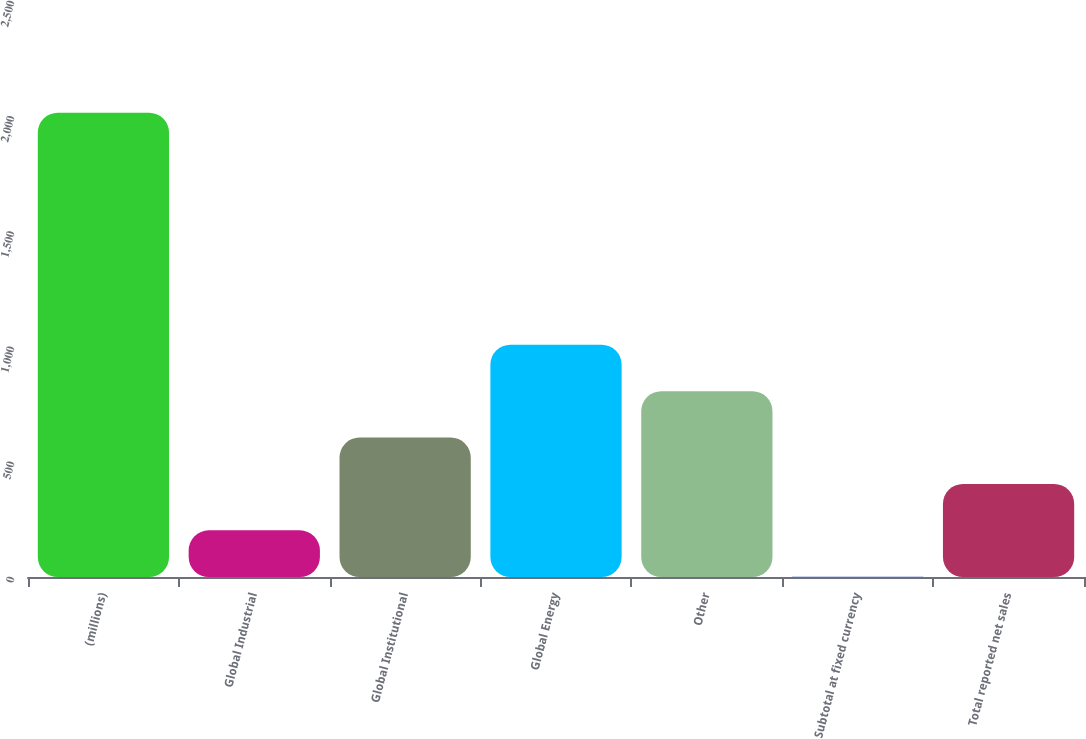Convert chart to OTSL. <chart><loc_0><loc_0><loc_500><loc_500><bar_chart><fcel>(millions)<fcel>Global Industrial<fcel>Global Institutional<fcel>Global Energy<fcel>Other<fcel>Subtotal at fixed currency<fcel>Total reported net sales<nl><fcel>2015<fcel>202.4<fcel>605.2<fcel>1008<fcel>806.6<fcel>1<fcel>403.8<nl></chart> 